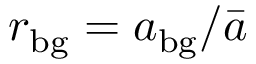Convert formula to latex. <formula><loc_0><loc_0><loc_500><loc_500>r _ { b g } = a _ { b g } / \bar { a }</formula> 